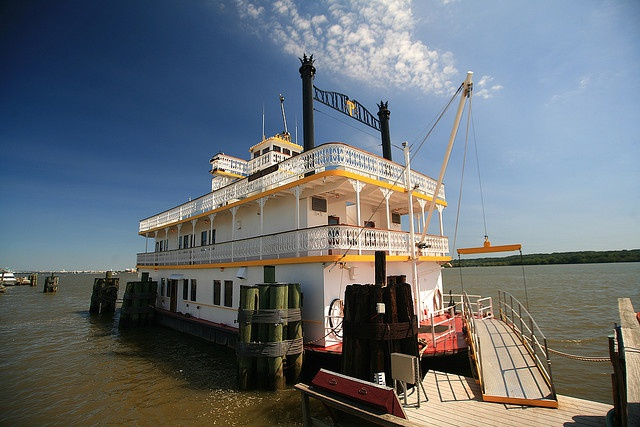Describe the objects in this image and their specific colors. I can see boat in black, gray, darkgray, and ivory tones, boat in black, white, gray, and darkgreen tones, and boat in black, olive, tan, and gray tones in this image. 